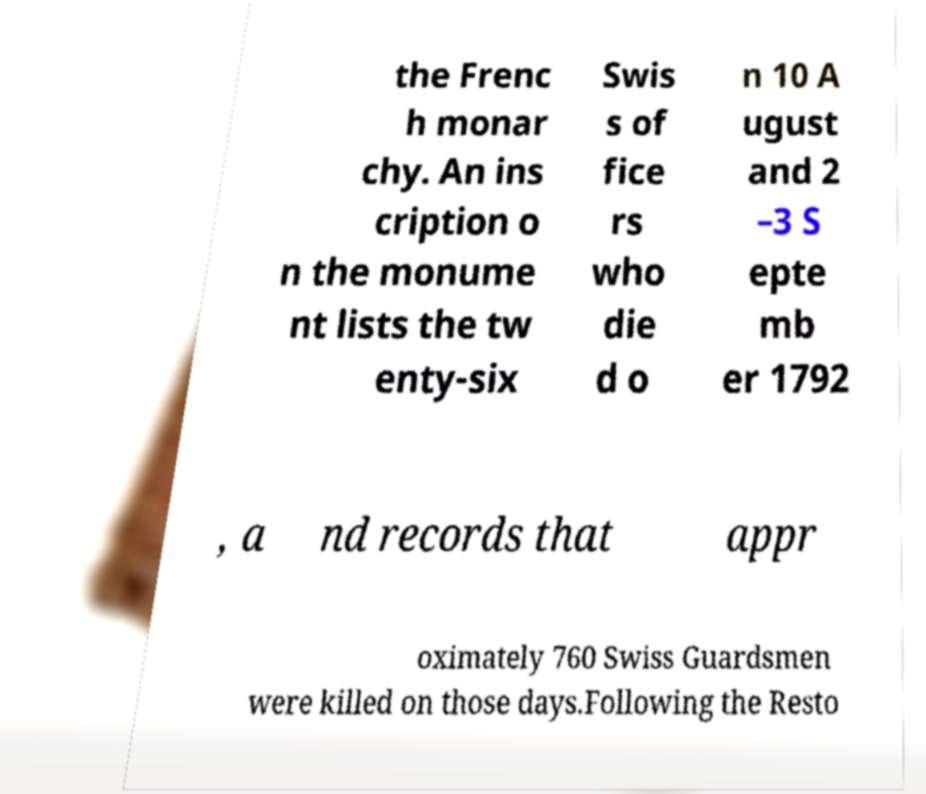Please identify and transcribe the text found in this image. the Frenc h monar chy. An ins cription o n the monume nt lists the tw enty-six Swis s of fice rs who die d o n 10 A ugust and 2 –3 S epte mb er 1792 , a nd records that appr oximately 760 Swiss Guardsmen were killed on those days.Following the Resto 